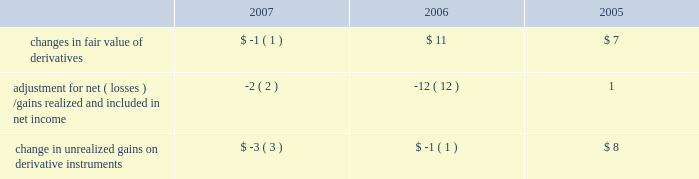Notes to consolidated financial statements ( continued ) note 6 2014shareholders 2019 equity ( continued ) the table summarizes activity in other comprehensive income related to derivatives , net of taxes , held by the company ( in millions ) : .
The tax effect related to the changes in fair value of derivatives was $ 1 million , $ ( 8 ) million , and $ ( 3 ) million for 2007 , 2006 , and 2005 , respectively .
The tax effect related to derivative gains/losses reclassified from other comprehensive income to net income was $ 2 million , $ 8 million , and $ ( 2 ) million for 2007 , 2006 , and 2005 , respectively .
Employee benefit plans 2003 employee stock plan the 2003 employee stock plan ( the 2018 20182003 plan 2019 2019 ) is a shareholder approved plan that provides for broad- based grants to employees , including executive officers .
Based on the terms of individual option grants , options granted under the 2003 plan generally expire 7 to 10 years after the grant date and generally become exercisable over a period of four years , based on continued employment , with either annual or quarterly vesting .
The 2003 plan permits the granting of incentive stock options , nonstatutory stock options , rsus , stock appreciation rights , stock purchase rights and performance-based awards .
During 2007 , the company 2019s shareholders approved an amendment to the 2003 plan to increase the number of shares authorized for issuance by 28 million shares .
1997 employee stock option plan in august 1997 , the company 2019s board of directors approved the 1997 employee stock option plan ( the 2018 20181997 plan 2019 2019 ) , a non-shareholder approved plan for grants of stock options to employees who are not officers of the company .
Based on the terms of individual option grants , options granted under the 1997 plan generally expire 7 to 10 years after the grant date and generally become exercisable over a period of four years , based on continued employment , with either annual or quarterly vesting .
In october 2003 , the company terminated the 1997 plan and no new options can be granted from this plan .
1997 director stock option plan in august 1997 , the company 2019s board of directors adopted a director stock option plan ( the 2018 2018director plan 2019 2019 ) for non-employee directors of the company , which was approved by shareholders in 1998 .
Pursuant to the director plan , the company 2019s non-employee directors are granted an option to acquire 30000 shares of common stock upon their initial election to the board ( 2018 2018initial options 2019 2019 ) .
The initial options vest and become exercisable in three equal annual installments on each of the first through third anniversaries of the grant date .
On the fourth anniversary of a non-employee director 2019s initial election to the board and on each subsequent anniversary thereafter , the director will be entitled to receive an option to acquire 10000 shares of common stock ( 2018 2018annual options 2019 2019 ) .
Annual options are fully vested and immediately exercisable on their date of grant .
Rule 10b5-1 trading plans certain of the company 2019s executive officers , including mr .
Timothy d .
Cook , mr .
Peter oppenheimer , mr .
Philip w .
Schiller , and dr .
Bertrand serlet , have entered into trading plans pursuant to .
What was the smallest change in changes in fair value of derivatives , in millions? 
Computations: table_min(changes in fair value of derivatives, none)
Answer: -1.0. 